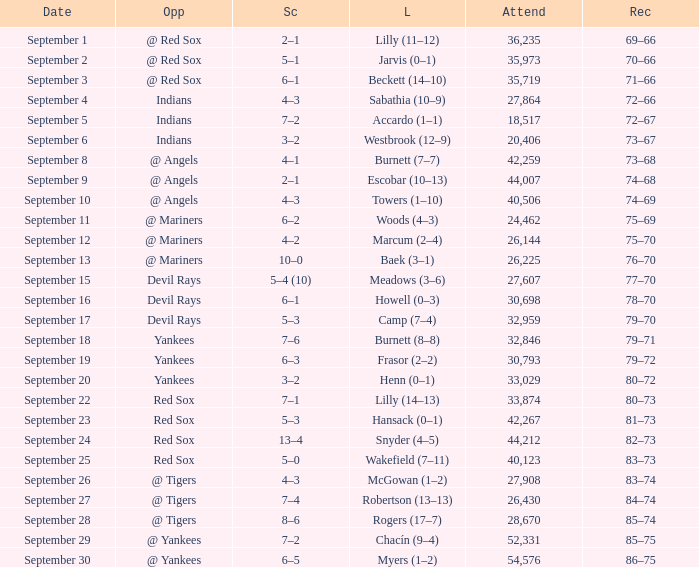Which opponent plays on September 19? Yankees. 